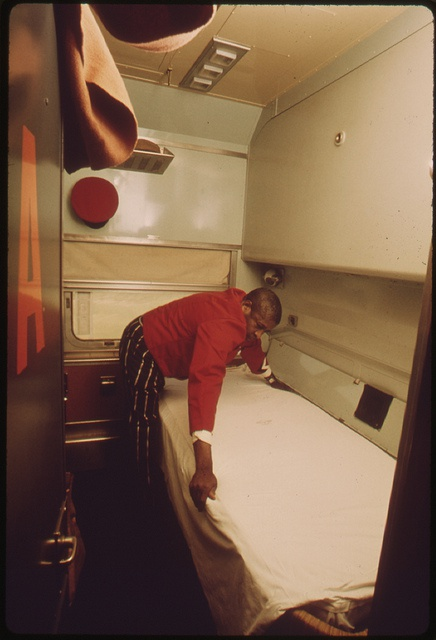Describe the objects in this image and their specific colors. I can see bed in black, tan, and maroon tones and people in black, maroon, and brown tones in this image. 